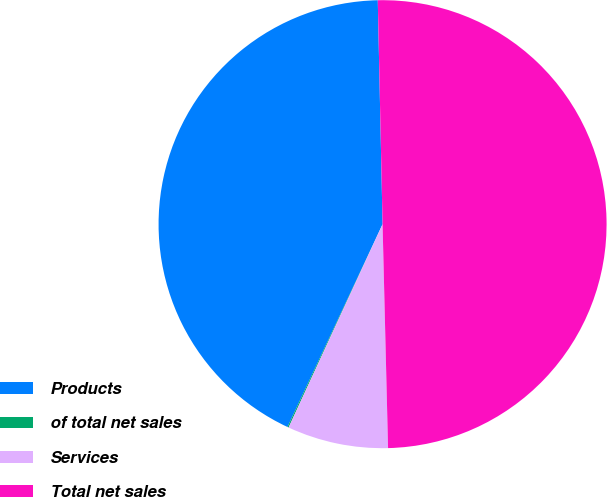Convert chart to OTSL. <chart><loc_0><loc_0><loc_500><loc_500><pie_chart><fcel>Products<fcel>of total net sales<fcel>Services<fcel>Total net sales<nl><fcel>42.68%<fcel>0.09%<fcel>7.28%<fcel>49.95%<nl></chart> 